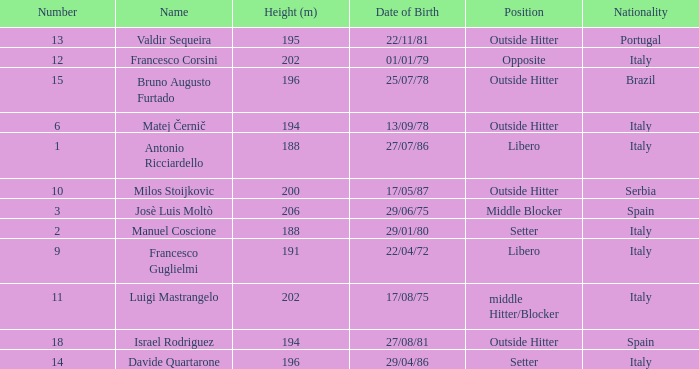Parse the full table. {'header': ['Number', 'Name', 'Height (m)', 'Date of Birth', 'Position', 'Nationality'], 'rows': [['13', 'Valdir Sequeira', '195', '22/11/81', 'Outside Hitter', 'Portugal'], ['12', 'Francesco Corsini', '202', '01/01/79', 'Opposite', 'Italy'], ['15', 'Bruno Augusto Furtado', '196', '25/07/78', 'Outside Hitter', 'Brazil'], ['6', 'Matej Černič', '194', '13/09/78', 'Outside Hitter', 'Italy'], ['1', 'Antonio Ricciardello', '188', '27/07/86', 'Libero', 'Italy'], ['10', 'Milos Stoijkovic', '200', '17/05/87', 'Outside Hitter', 'Serbia'], ['3', 'Josè Luis Moltò', '206', '29/06/75', 'Middle Blocker', 'Spain'], ['2', 'Manuel Coscione', '188', '29/01/80', 'Setter', 'Italy'], ['9', 'Francesco Guglielmi', '191', '22/04/72', 'Libero', 'Italy'], ['11', 'Luigi Mastrangelo', '202', '17/08/75', 'middle Hitter/Blocker', 'Italy'], ['18', 'Israel Rodriguez', '194', '27/08/81', 'Outside Hitter', 'Spain'], ['14', 'Davide Quartarone', '196', '29/04/86', 'Setter', 'Italy']]} Name the height for date of birth being 17/08/75 202.0. 